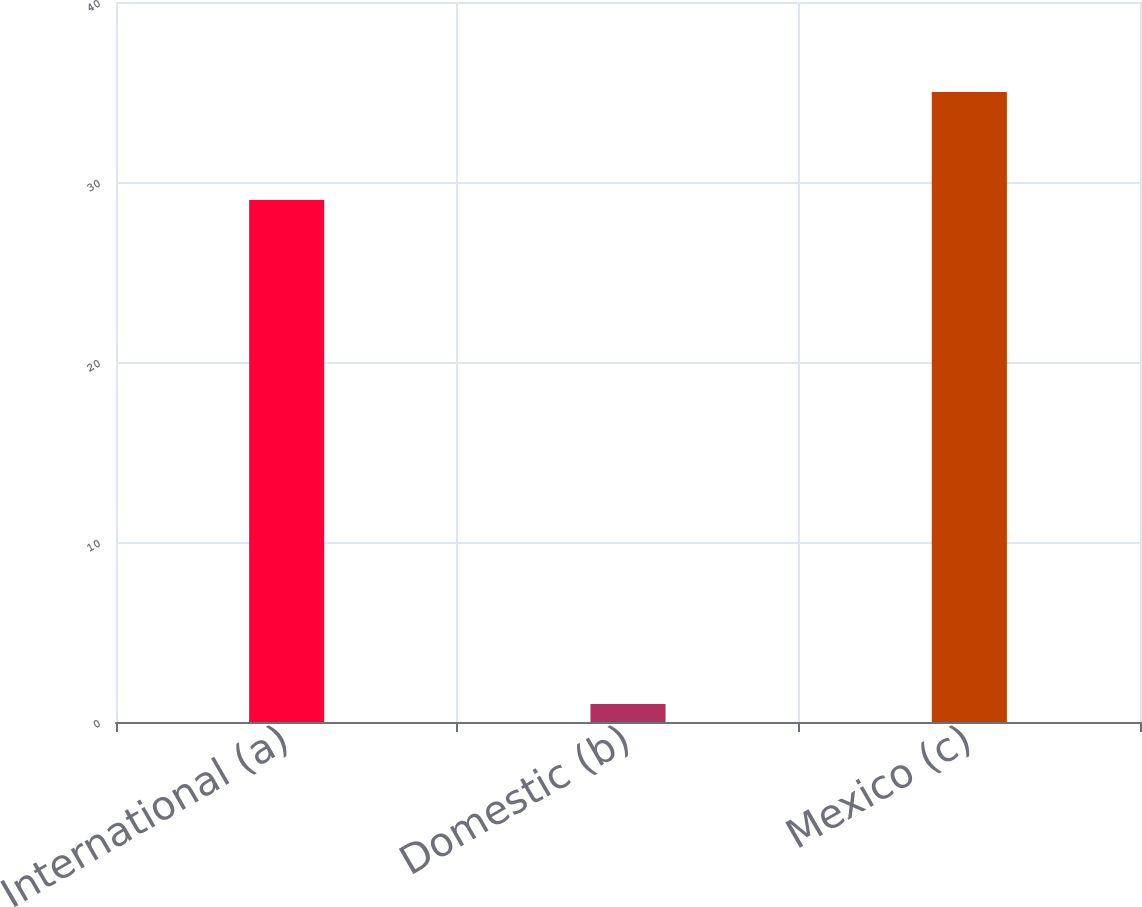Convert chart to OTSL. <chart><loc_0><loc_0><loc_500><loc_500><bar_chart><fcel>International (a)<fcel>Domestic (b)<fcel>Mexico (c)<nl><fcel>29<fcel>1<fcel>35<nl></chart> 